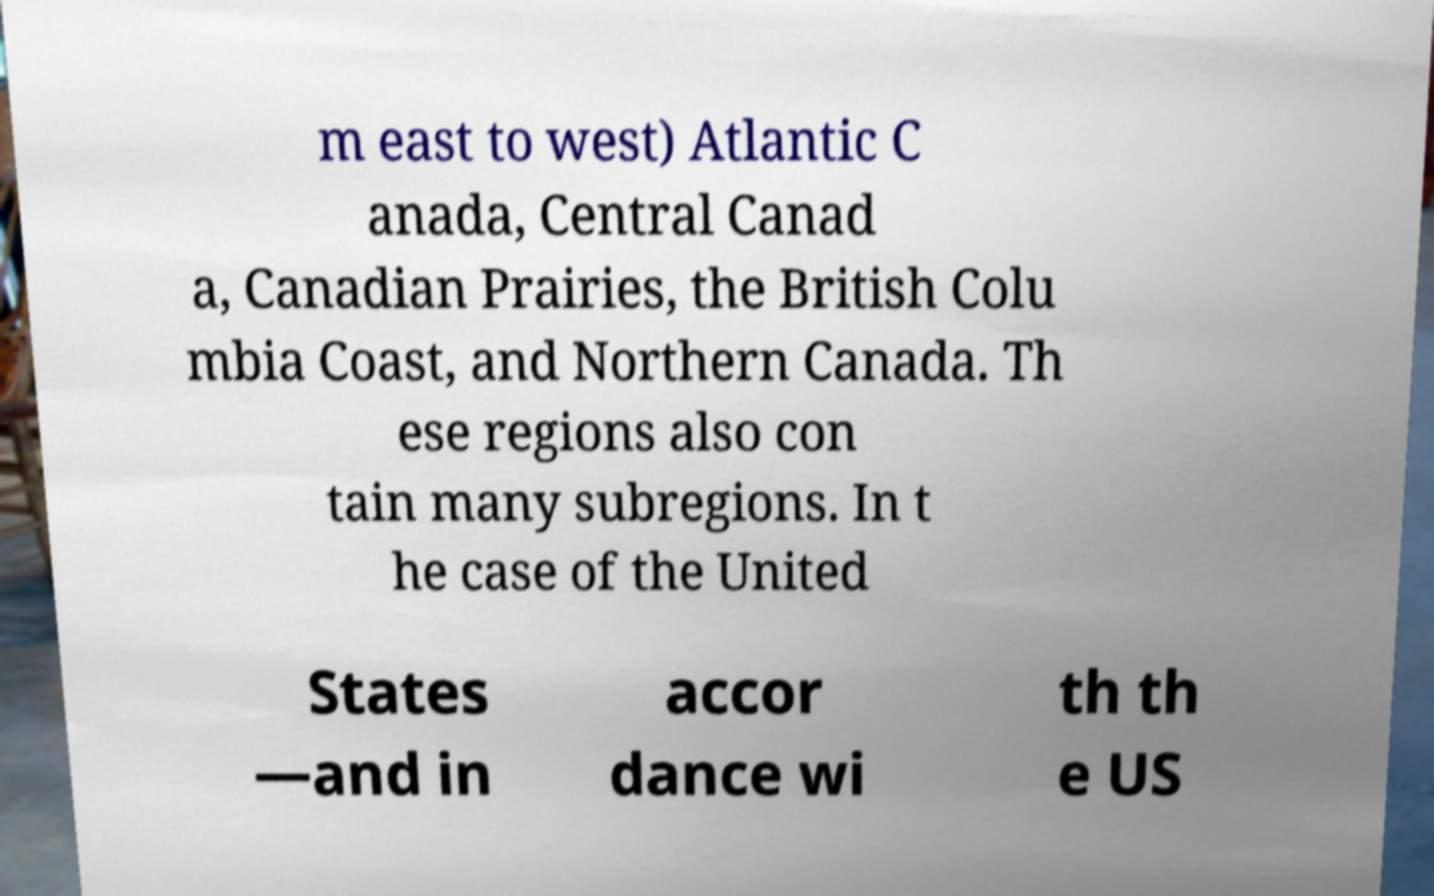Can you read and provide the text displayed in the image?This photo seems to have some interesting text. Can you extract and type it out for me? m east to west) Atlantic C anada, Central Canad a, Canadian Prairies, the British Colu mbia Coast, and Northern Canada. Th ese regions also con tain many subregions. In t he case of the United States —and in accor dance wi th th e US 